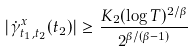Convert formula to latex. <formula><loc_0><loc_0><loc_500><loc_500>| \dot { \gamma } ^ { x } _ { t _ { 1 } , t _ { 2 } } ( t _ { 2 } ) | \geq \frac { K _ { 2 } ( \log T ) ^ { 2 / \beta } } { 2 ^ { \beta / ( \beta - 1 ) } }</formula> 